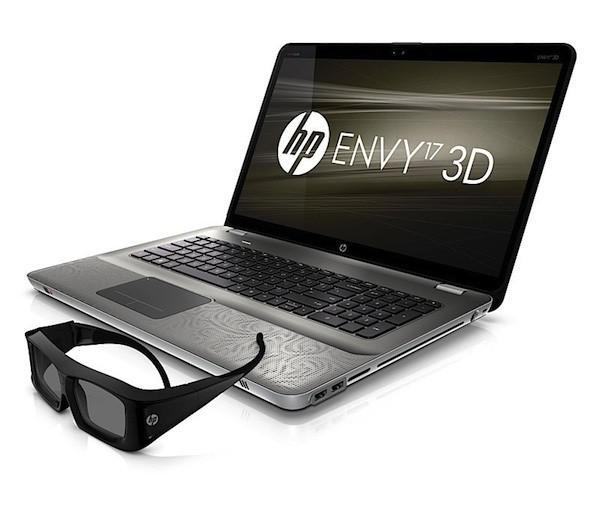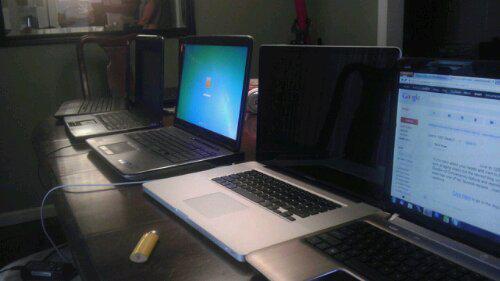The first image is the image on the left, the second image is the image on the right. Evaluate the accuracy of this statement regarding the images: "There are more laptop-type devices in the right image than in the left.". Is it true? Answer yes or no. Yes. The first image is the image on the left, the second image is the image on the right. Evaluate the accuracy of this statement regarding the images: "All the screens in the image on the right are turned off.". Is it true? Answer yes or no. No. 